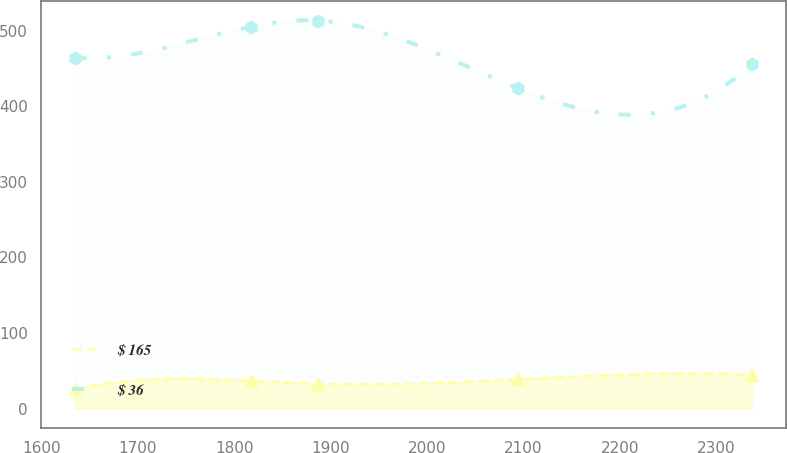Convert chart to OTSL. <chart><loc_0><loc_0><loc_500><loc_500><line_chart><ecel><fcel>$ 165<fcel>$ 36<nl><fcel>1634.57<fcel>25.61<fcel>463.89<nl><fcel>1816.81<fcel>36.65<fcel>505.03<nl><fcel>1887.03<fcel>32.68<fcel>513.24<nl><fcel>2094.14<fcel>38.58<fcel>423.78<nl><fcel>2336.77<fcel>44.88<fcel>455.51<nl></chart> 